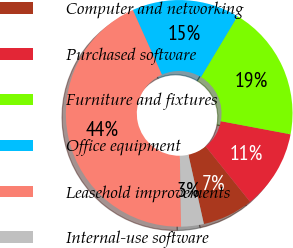Convert chart to OTSL. <chart><loc_0><loc_0><loc_500><loc_500><pie_chart><fcel>Computer and networking<fcel>Purchased software<fcel>Furniture and fixtures<fcel>Office equipment<fcel>Leasehold improvements<fcel>Internal-use software<nl><fcel>7.26%<fcel>11.29%<fcel>19.35%<fcel>15.32%<fcel>43.55%<fcel>3.23%<nl></chart> 